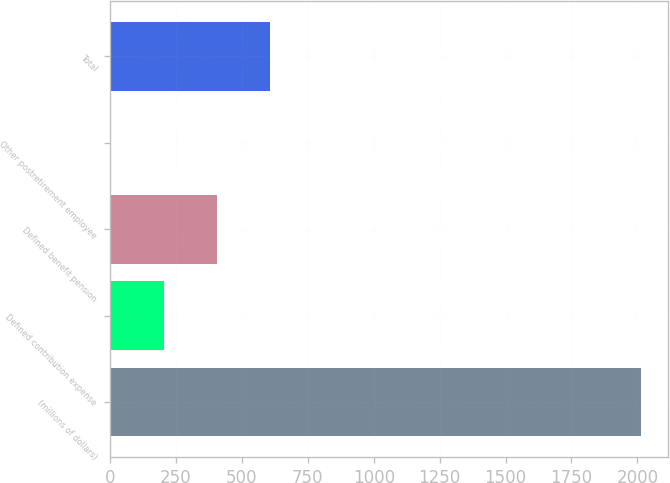<chart> <loc_0><loc_0><loc_500><loc_500><bar_chart><fcel>(millions of dollars)<fcel>Defined contribution expense<fcel>Defined benefit pension<fcel>Other postretirement employee<fcel>Total<nl><fcel>2015<fcel>204.47<fcel>405.64<fcel>3.3<fcel>606.81<nl></chart> 